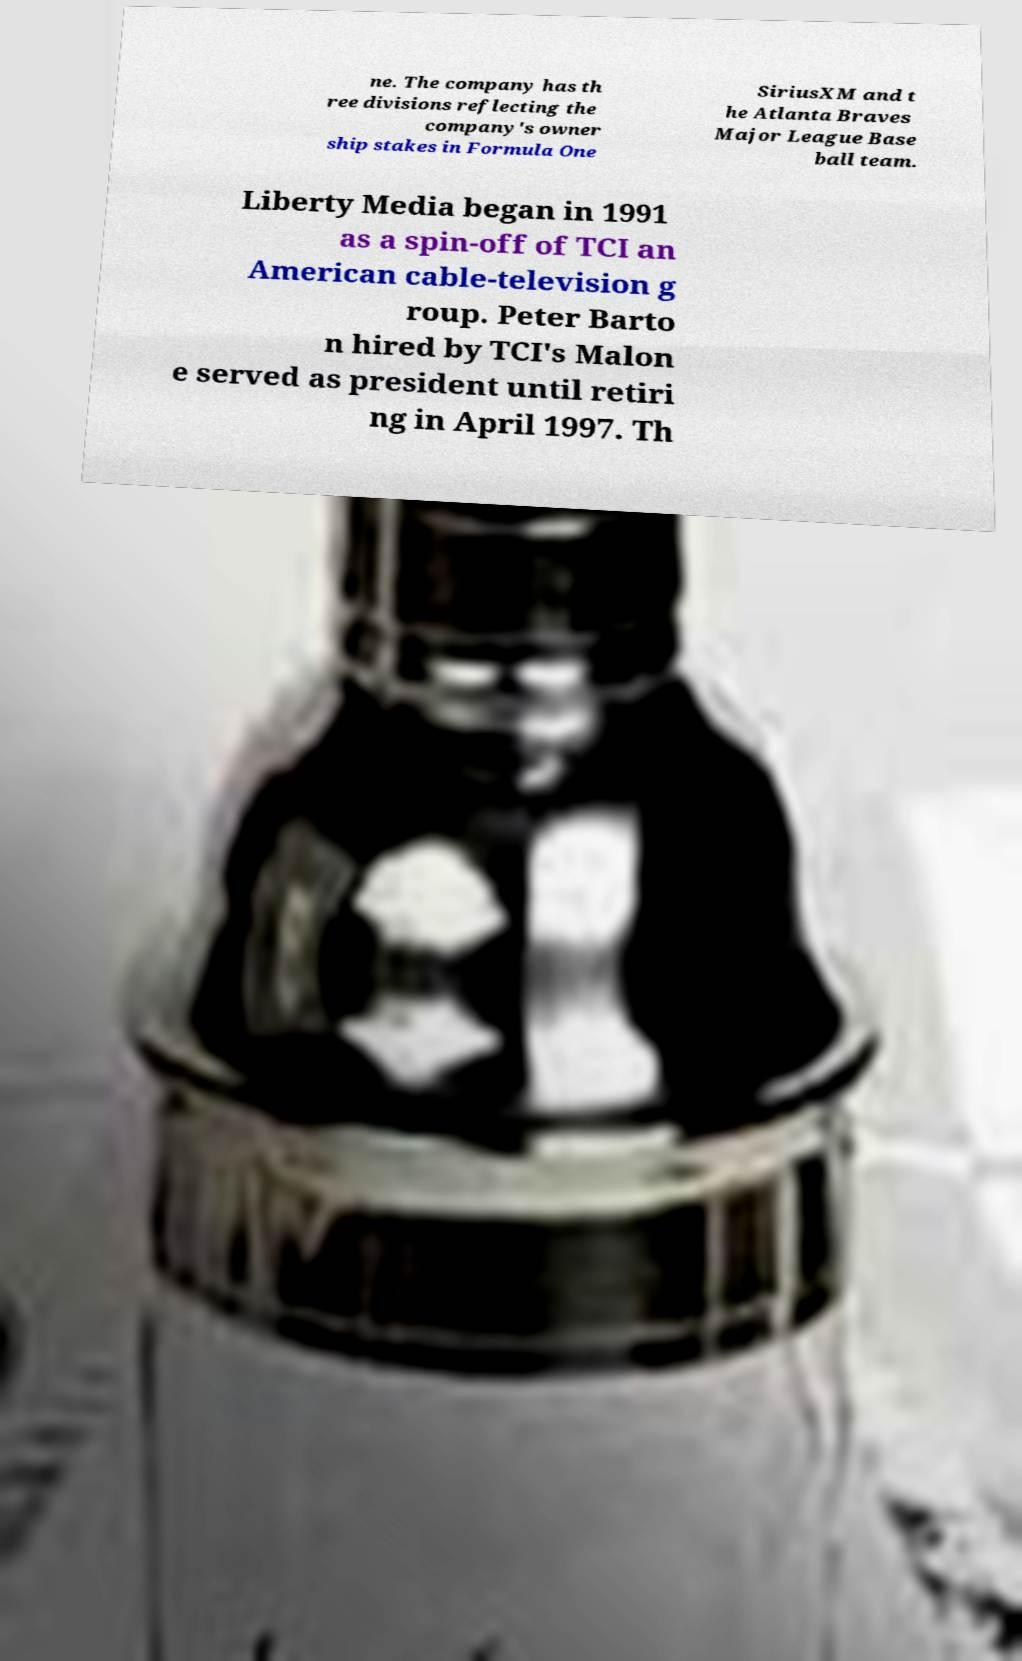Can you accurately transcribe the text from the provided image for me? ne. The company has th ree divisions reflecting the company's owner ship stakes in Formula One SiriusXM and t he Atlanta Braves Major League Base ball team. Liberty Media began in 1991 as a spin-off of TCI an American cable-television g roup. Peter Barto n hired by TCI's Malon e served as president until retiri ng in April 1997. Th 